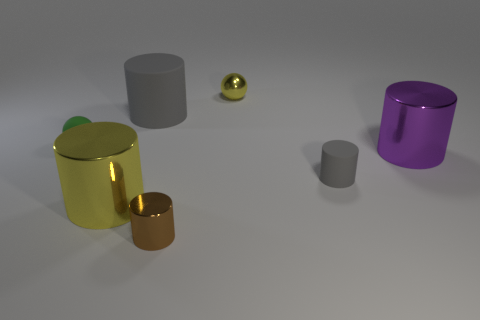Subtract all big yellow metallic cylinders. How many cylinders are left? 4 Subtract all red blocks. How many gray cylinders are left? 2 Subtract 3 cylinders. How many cylinders are left? 2 Subtract all purple cylinders. How many cylinders are left? 4 Subtract all yellow cylinders. Subtract all blue spheres. How many cylinders are left? 4 Subtract all spheres. How many objects are left? 5 Add 2 brown cylinders. How many objects exist? 9 Subtract all tiny yellow spheres. Subtract all yellow rubber cylinders. How many objects are left? 6 Add 7 small gray cylinders. How many small gray cylinders are left? 8 Add 7 spheres. How many spheres exist? 9 